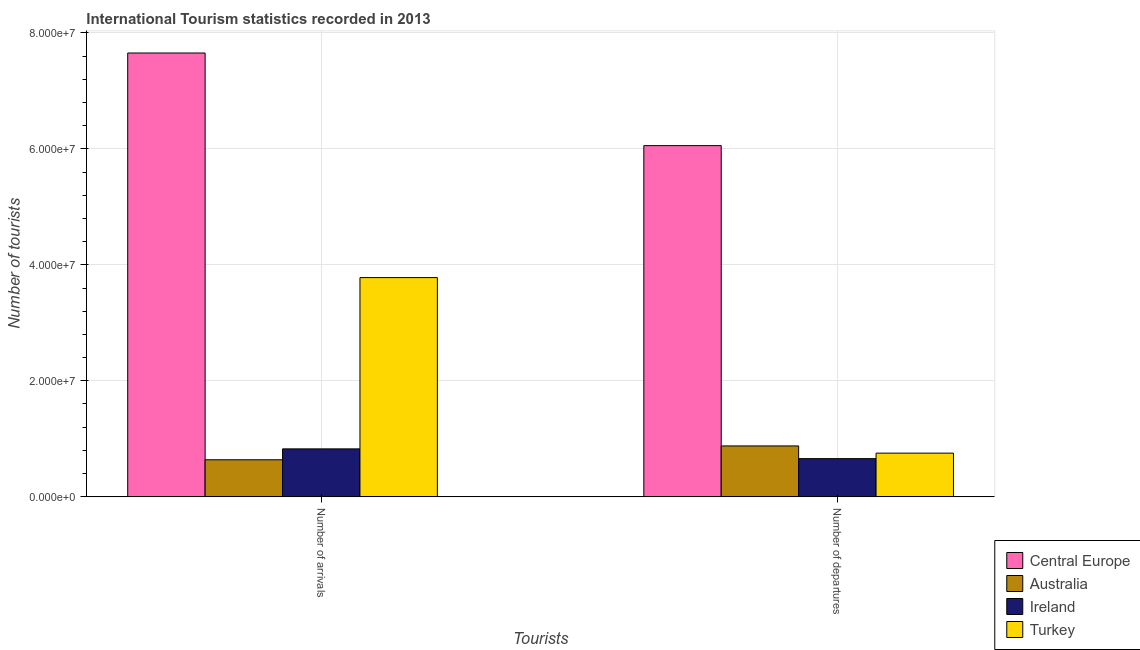Are the number of bars per tick equal to the number of legend labels?
Offer a very short reply. Yes. How many bars are there on the 1st tick from the left?
Offer a terse response. 4. How many bars are there on the 1st tick from the right?
Keep it short and to the point. 4. What is the label of the 2nd group of bars from the left?
Your answer should be very brief. Number of departures. What is the number of tourist arrivals in Turkey?
Provide a succinct answer. 3.78e+07. Across all countries, what is the maximum number of tourist arrivals?
Provide a succinct answer. 7.65e+07. Across all countries, what is the minimum number of tourist departures?
Give a very brief answer. 6.58e+06. In which country was the number of tourist departures maximum?
Offer a very short reply. Central Europe. What is the total number of tourist arrivals in the graph?
Offer a very short reply. 1.29e+08. What is the difference between the number of tourist arrivals in Australia and that in Ireland?
Your response must be concise. -1.88e+06. What is the difference between the number of tourist departures in Australia and the number of tourist arrivals in Central Europe?
Ensure brevity in your answer.  -6.78e+07. What is the average number of tourist arrivals per country?
Your answer should be very brief. 3.22e+07. What is the difference between the number of tourist arrivals and number of tourist departures in Ireland?
Make the answer very short. 1.68e+06. In how many countries, is the number of tourist departures greater than 20000000 ?
Offer a very short reply. 1. What is the ratio of the number of tourist arrivals in Australia to that in Ireland?
Your answer should be compact. 0.77. What does the 3rd bar from the left in Number of arrivals represents?
Ensure brevity in your answer.  Ireland. What does the 4th bar from the right in Number of departures represents?
Make the answer very short. Central Europe. How many countries are there in the graph?
Your answer should be very brief. 4. What is the difference between two consecutive major ticks on the Y-axis?
Make the answer very short. 2.00e+07. Are the values on the major ticks of Y-axis written in scientific E-notation?
Offer a very short reply. Yes. Does the graph contain any zero values?
Your answer should be compact. No. Does the graph contain grids?
Offer a terse response. Yes. How are the legend labels stacked?
Ensure brevity in your answer.  Vertical. What is the title of the graph?
Keep it short and to the point. International Tourism statistics recorded in 2013. What is the label or title of the X-axis?
Your response must be concise. Tourists. What is the label or title of the Y-axis?
Provide a succinct answer. Number of tourists. What is the Number of tourists of Central Europe in Number of arrivals?
Offer a terse response. 7.65e+07. What is the Number of tourists in Australia in Number of arrivals?
Provide a short and direct response. 6.38e+06. What is the Number of tourists in Ireland in Number of arrivals?
Offer a terse response. 8.26e+06. What is the Number of tourists of Turkey in Number of arrivals?
Provide a succinct answer. 3.78e+07. What is the Number of tourists of Central Europe in Number of departures?
Keep it short and to the point. 6.06e+07. What is the Number of tourists in Australia in Number of departures?
Keep it short and to the point. 8.77e+06. What is the Number of tourists in Ireland in Number of departures?
Make the answer very short. 6.58e+06. What is the Number of tourists in Turkey in Number of departures?
Offer a very short reply. 7.53e+06. Across all Tourists, what is the maximum Number of tourists in Central Europe?
Ensure brevity in your answer.  7.65e+07. Across all Tourists, what is the maximum Number of tourists of Australia?
Provide a succinct answer. 8.77e+06. Across all Tourists, what is the maximum Number of tourists of Ireland?
Your response must be concise. 8.26e+06. Across all Tourists, what is the maximum Number of tourists of Turkey?
Your answer should be very brief. 3.78e+07. Across all Tourists, what is the minimum Number of tourists of Central Europe?
Keep it short and to the point. 6.06e+07. Across all Tourists, what is the minimum Number of tourists in Australia?
Ensure brevity in your answer.  6.38e+06. Across all Tourists, what is the minimum Number of tourists in Ireland?
Provide a short and direct response. 6.58e+06. Across all Tourists, what is the minimum Number of tourists of Turkey?
Offer a very short reply. 7.53e+06. What is the total Number of tourists in Central Europe in the graph?
Ensure brevity in your answer.  1.37e+08. What is the total Number of tourists in Australia in the graph?
Your response must be concise. 1.52e+07. What is the total Number of tourists of Ireland in the graph?
Provide a short and direct response. 1.48e+07. What is the total Number of tourists of Turkey in the graph?
Ensure brevity in your answer.  4.53e+07. What is the difference between the Number of tourists of Central Europe in Number of arrivals and that in Number of departures?
Ensure brevity in your answer.  1.60e+07. What is the difference between the Number of tourists of Australia in Number of arrivals and that in Number of departures?
Offer a very short reply. -2.39e+06. What is the difference between the Number of tourists of Ireland in Number of arrivals and that in Number of departures?
Provide a short and direct response. 1.68e+06. What is the difference between the Number of tourists in Turkey in Number of arrivals and that in Number of departures?
Your response must be concise. 3.03e+07. What is the difference between the Number of tourists in Central Europe in Number of arrivals and the Number of tourists in Australia in Number of departures?
Your response must be concise. 6.78e+07. What is the difference between the Number of tourists in Central Europe in Number of arrivals and the Number of tourists in Ireland in Number of departures?
Give a very brief answer. 6.99e+07. What is the difference between the Number of tourists in Central Europe in Number of arrivals and the Number of tourists in Turkey in Number of departures?
Your answer should be very brief. 6.90e+07. What is the difference between the Number of tourists in Australia in Number of arrivals and the Number of tourists in Ireland in Number of departures?
Provide a succinct answer. -1.97e+05. What is the difference between the Number of tourists of Australia in Number of arrivals and the Number of tourists of Turkey in Number of departures?
Offer a very short reply. -1.14e+06. What is the difference between the Number of tourists in Ireland in Number of arrivals and the Number of tourists in Turkey in Number of departures?
Provide a succinct answer. 7.34e+05. What is the average Number of tourists of Central Europe per Tourists?
Your answer should be very brief. 6.85e+07. What is the average Number of tourists of Australia per Tourists?
Your answer should be compact. 7.58e+06. What is the average Number of tourists of Ireland per Tourists?
Make the answer very short. 7.42e+06. What is the average Number of tourists in Turkey per Tourists?
Make the answer very short. 2.27e+07. What is the difference between the Number of tourists in Central Europe and Number of tourists in Australia in Number of arrivals?
Provide a succinct answer. 7.01e+07. What is the difference between the Number of tourists of Central Europe and Number of tourists of Ireland in Number of arrivals?
Offer a terse response. 6.83e+07. What is the difference between the Number of tourists in Central Europe and Number of tourists in Turkey in Number of arrivals?
Offer a very short reply. 3.87e+07. What is the difference between the Number of tourists of Australia and Number of tourists of Ireland in Number of arrivals?
Your answer should be compact. -1.88e+06. What is the difference between the Number of tourists of Australia and Number of tourists of Turkey in Number of arrivals?
Offer a terse response. -3.14e+07. What is the difference between the Number of tourists in Ireland and Number of tourists in Turkey in Number of arrivals?
Make the answer very short. -2.95e+07. What is the difference between the Number of tourists of Central Europe and Number of tourists of Australia in Number of departures?
Your response must be concise. 5.18e+07. What is the difference between the Number of tourists in Central Europe and Number of tourists in Ireland in Number of departures?
Offer a terse response. 5.40e+07. What is the difference between the Number of tourists in Central Europe and Number of tourists in Turkey in Number of departures?
Your answer should be compact. 5.30e+07. What is the difference between the Number of tourists in Australia and Number of tourists in Ireland in Number of departures?
Your answer should be very brief. 2.19e+06. What is the difference between the Number of tourists of Australia and Number of tourists of Turkey in Number of departures?
Offer a terse response. 1.24e+06. What is the difference between the Number of tourists of Ireland and Number of tourists of Turkey in Number of departures?
Ensure brevity in your answer.  -9.47e+05. What is the ratio of the Number of tourists of Central Europe in Number of arrivals to that in Number of departures?
Your answer should be very brief. 1.26. What is the ratio of the Number of tourists of Australia in Number of arrivals to that in Number of departures?
Offer a very short reply. 0.73. What is the ratio of the Number of tourists of Ireland in Number of arrivals to that in Number of departures?
Provide a succinct answer. 1.26. What is the ratio of the Number of tourists in Turkey in Number of arrivals to that in Number of departures?
Your answer should be very brief. 5.02. What is the difference between the highest and the second highest Number of tourists of Central Europe?
Your answer should be compact. 1.60e+07. What is the difference between the highest and the second highest Number of tourists of Australia?
Provide a short and direct response. 2.39e+06. What is the difference between the highest and the second highest Number of tourists of Ireland?
Provide a short and direct response. 1.68e+06. What is the difference between the highest and the second highest Number of tourists of Turkey?
Offer a terse response. 3.03e+07. What is the difference between the highest and the lowest Number of tourists in Central Europe?
Your response must be concise. 1.60e+07. What is the difference between the highest and the lowest Number of tourists of Australia?
Your answer should be compact. 2.39e+06. What is the difference between the highest and the lowest Number of tourists of Ireland?
Your answer should be very brief. 1.68e+06. What is the difference between the highest and the lowest Number of tourists in Turkey?
Offer a terse response. 3.03e+07. 